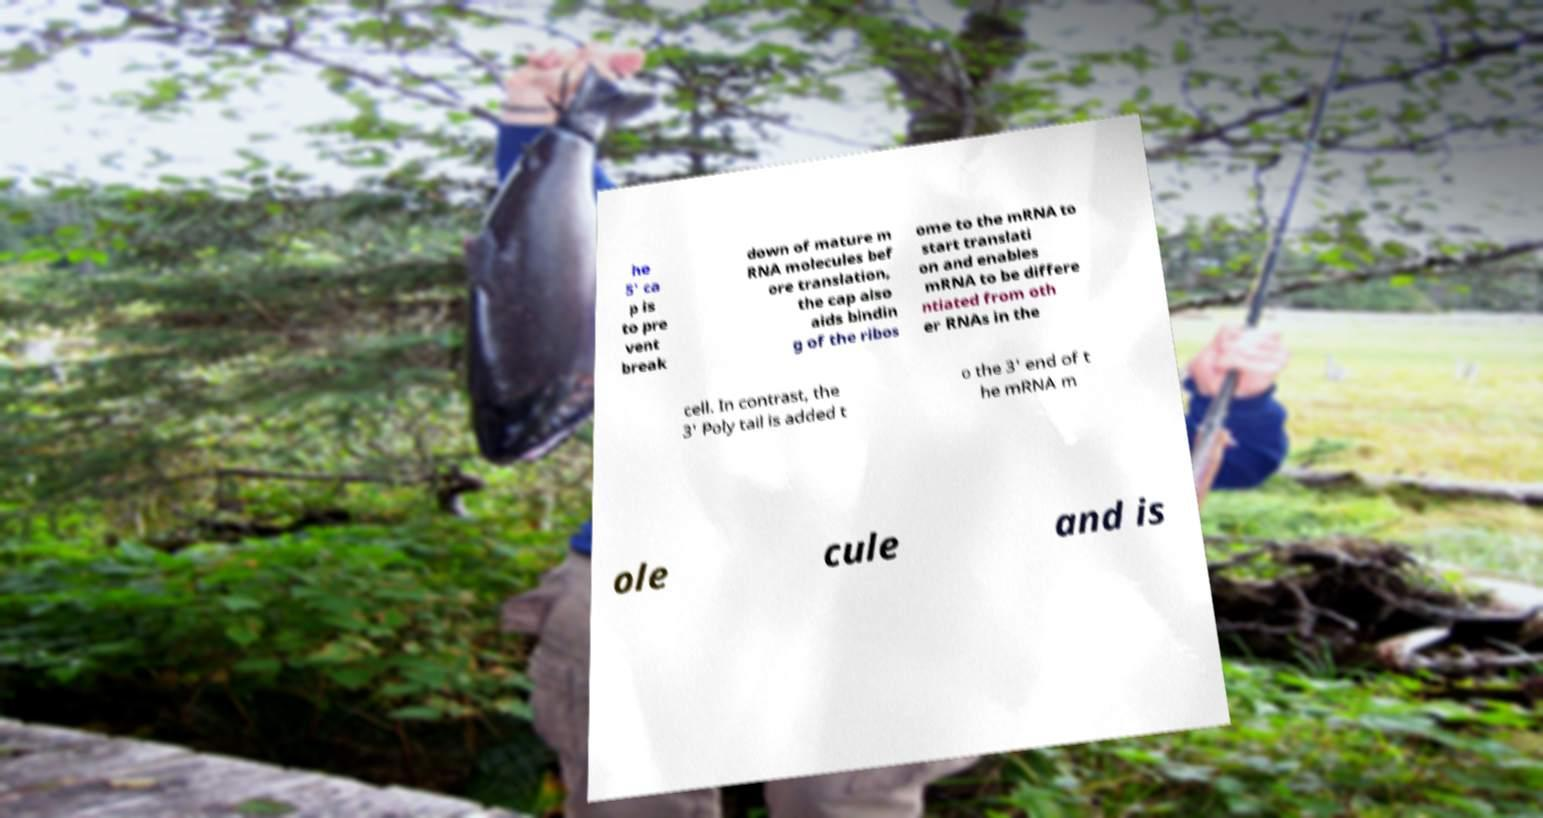Please read and relay the text visible in this image. What does it say? he 5' ca p is to pre vent break down of mature m RNA molecules bef ore translation, the cap also aids bindin g of the ribos ome to the mRNA to start translati on and enables mRNA to be differe ntiated from oth er RNAs in the cell. In contrast, the 3' Poly tail is added t o the 3' end of t he mRNA m ole cule and is 